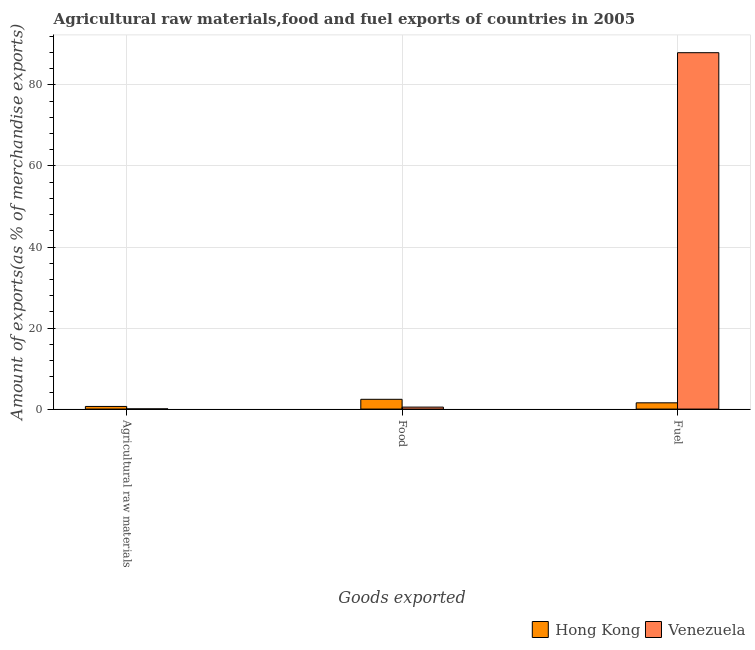How many different coloured bars are there?
Ensure brevity in your answer.  2. Are the number of bars per tick equal to the number of legend labels?
Keep it short and to the point. Yes. Are the number of bars on each tick of the X-axis equal?
Make the answer very short. Yes. How many bars are there on the 1st tick from the right?
Provide a succinct answer. 2. What is the label of the 3rd group of bars from the left?
Offer a terse response. Fuel. What is the percentage of fuel exports in Hong Kong?
Ensure brevity in your answer.  1.54. Across all countries, what is the maximum percentage of fuel exports?
Give a very brief answer. 87.96. Across all countries, what is the minimum percentage of raw materials exports?
Make the answer very short. 0.05. In which country was the percentage of raw materials exports maximum?
Provide a succinct answer. Hong Kong. In which country was the percentage of fuel exports minimum?
Offer a very short reply. Hong Kong. What is the total percentage of raw materials exports in the graph?
Your answer should be compact. 0.7. What is the difference between the percentage of food exports in Hong Kong and that in Venezuela?
Make the answer very short. 1.92. What is the difference between the percentage of fuel exports in Hong Kong and the percentage of raw materials exports in Venezuela?
Your answer should be very brief. 1.5. What is the average percentage of raw materials exports per country?
Your response must be concise. 0.35. What is the difference between the percentage of raw materials exports and percentage of fuel exports in Venezuela?
Your answer should be very brief. -87.91. What is the ratio of the percentage of food exports in Hong Kong to that in Venezuela?
Give a very brief answer. 4.95. Is the percentage of fuel exports in Venezuela less than that in Hong Kong?
Provide a succinct answer. No. Is the difference between the percentage of food exports in Hong Kong and Venezuela greater than the difference between the percentage of fuel exports in Hong Kong and Venezuela?
Give a very brief answer. Yes. What is the difference between the highest and the second highest percentage of fuel exports?
Offer a terse response. 86.41. What is the difference between the highest and the lowest percentage of raw materials exports?
Ensure brevity in your answer.  0.6. What does the 1st bar from the left in Fuel represents?
Offer a very short reply. Hong Kong. What does the 2nd bar from the right in Fuel represents?
Your answer should be very brief. Hong Kong. Is it the case that in every country, the sum of the percentage of raw materials exports and percentage of food exports is greater than the percentage of fuel exports?
Your response must be concise. No. How many bars are there?
Your answer should be very brief. 6. Are all the bars in the graph horizontal?
Your response must be concise. No. How many countries are there in the graph?
Your response must be concise. 2. Does the graph contain any zero values?
Offer a terse response. No. Does the graph contain grids?
Your answer should be compact. Yes. What is the title of the graph?
Provide a succinct answer. Agricultural raw materials,food and fuel exports of countries in 2005. What is the label or title of the X-axis?
Provide a succinct answer. Goods exported. What is the label or title of the Y-axis?
Offer a very short reply. Amount of exports(as % of merchandise exports). What is the Amount of exports(as % of merchandise exports) of Hong Kong in Agricultural raw materials?
Give a very brief answer. 0.65. What is the Amount of exports(as % of merchandise exports) in Venezuela in Agricultural raw materials?
Keep it short and to the point. 0.05. What is the Amount of exports(as % of merchandise exports) of Hong Kong in Food?
Offer a terse response. 2.41. What is the Amount of exports(as % of merchandise exports) of Venezuela in Food?
Give a very brief answer. 0.49. What is the Amount of exports(as % of merchandise exports) of Hong Kong in Fuel?
Provide a succinct answer. 1.54. What is the Amount of exports(as % of merchandise exports) of Venezuela in Fuel?
Provide a short and direct response. 87.96. Across all Goods exported, what is the maximum Amount of exports(as % of merchandise exports) in Hong Kong?
Provide a succinct answer. 2.41. Across all Goods exported, what is the maximum Amount of exports(as % of merchandise exports) of Venezuela?
Offer a terse response. 87.96. Across all Goods exported, what is the minimum Amount of exports(as % of merchandise exports) of Hong Kong?
Ensure brevity in your answer.  0.65. Across all Goods exported, what is the minimum Amount of exports(as % of merchandise exports) in Venezuela?
Keep it short and to the point. 0.05. What is the total Amount of exports(as % of merchandise exports) of Hong Kong in the graph?
Your answer should be very brief. 4.61. What is the total Amount of exports(as % of merchandise exports) of Venezuela in the graph?
Your answer should be compact. 88.49. What is the difference between the Amount of exports(as % of merchandise exports) in Hong Kong in Agricultural raw materials and that in Food?
Keep it short and to the point. -1.76. What is the difference between the Amount of exports(as % of merchandise exports) in Venezuela in Agricultural raw materials and that in Food?
Provide a short and direct response. -0.44. What is the difference between the Amount of exports(as % of merchandise exports) of Hong Kong in Agricultural raw materials and that in Fuel?
Offer a terse response. -0.89. What is the difference between the Amount of exports(as % of merchandise exports) in Venezuela in Agricultural raw materials and that in Fuel?
Give a very brief answer. -87.91. What is the difference between the Amount of exports(as % of merchandise exports) of Hong Kong in Food and that in Fuel?
Give a very brief answer. 0.87. What is the difference between the Amount of exports(as % of merchandise exports) of Venezuela in Food and that in Fuel?
Keep it short and to the point. -87.47. What is the difference between the Amount of exports(as % of merchandise exports) of Hong Kong in Agricultural raw materials and the Amount of exports(as % of merchandise exports) of Venezuela in Food?
Your response must be concise. 0.16. What is the difference between the Amount of exports(as % of merchandise exports) of Hong Kong in Agricultural raw materials and the Amount of exports(as % of merchandise exports) of Venezuela in Fuel?
Offer a terse response. -87.31. What is the difference between the Amount of exports(as % of merchandise exports) of Hong Kong in Food and the Amount of exports(as % of merchandise exports) of Venezuela in Fuel?
Offer a terse response. -85.55. What is the average Amount of exports(as % of merchandise exports) of Hong Kong per Goods exported?
Offer a terse response. 1.54. What is the average Amount of exports(as % of merchandise exports) of Venezuela per Goods exported?
Offer a terse response. 29.5. What is the difference between the Amount of exports(as % of merchandise exports) in Hong Kong and Amount of exports(as % of merchandise exports) in Venezuela in Agricultural raw materials?
Your response must be concise. 0.6. What is the difference between the Amount of exports(as % of merchandise exports) of Hong Kong and Amount of exports(as % of merchandise exports) of Venezuela in Food?
Keep it short and to the point. 1.92. What is the difference between the Amount of exports(as % of merchandise exports) of Hong Kong and Amount of exports(as % of merchandise exports) of Venezuela in Fuel?
Offer a terse response. -86.41. What is the ratio of the Amount of exports(as % of merchandise exports) in Hong Kong in Agricultural raw materials to that in Food?
Make the answer very short. 0.27. What is the ratio of the Amount of exports(as % of merchandise exports) of Venezuela in Agricultural raw materials to that in Food?
Ensure brevity in your answer.  0.1. What is the ratio of the Amount of exports(as % of merchandise exports) in Hong Kong in Agricultural raw materials to that in Fuel?
Provide a succinct answer. 0.42. What is the ratio of the Amount of exports(as % of merchandise exports) of Hong Kong in Food to that in Fuel?
Your answer should be compact. 1.56. What is the ratio of the Amount of exports(as % of merchandise exports) of Venezuela in Food to that in Fuel?
Make the answer very short. 0.01. What is the difference between the highest and the second highest Amount of exports(as % of merchandise exports) of Hong Kong?
Give a very brief answer. 0.87. What is the difference between the highest and the second highest Amount of exports(as % of merchandise exports) in Venezuela?
Ensure brevity in your answer.  87.47. What is the difference between the highest and the lowest Amount of exports(as % of merchandise exports) of Hong Kong?
Provide a succinct answer. 1.76. What is the difference between the highest and the lowest Amount of exports(as % of merchandise exports) in Venezuela?
Your answer should be compact. 87.91. 